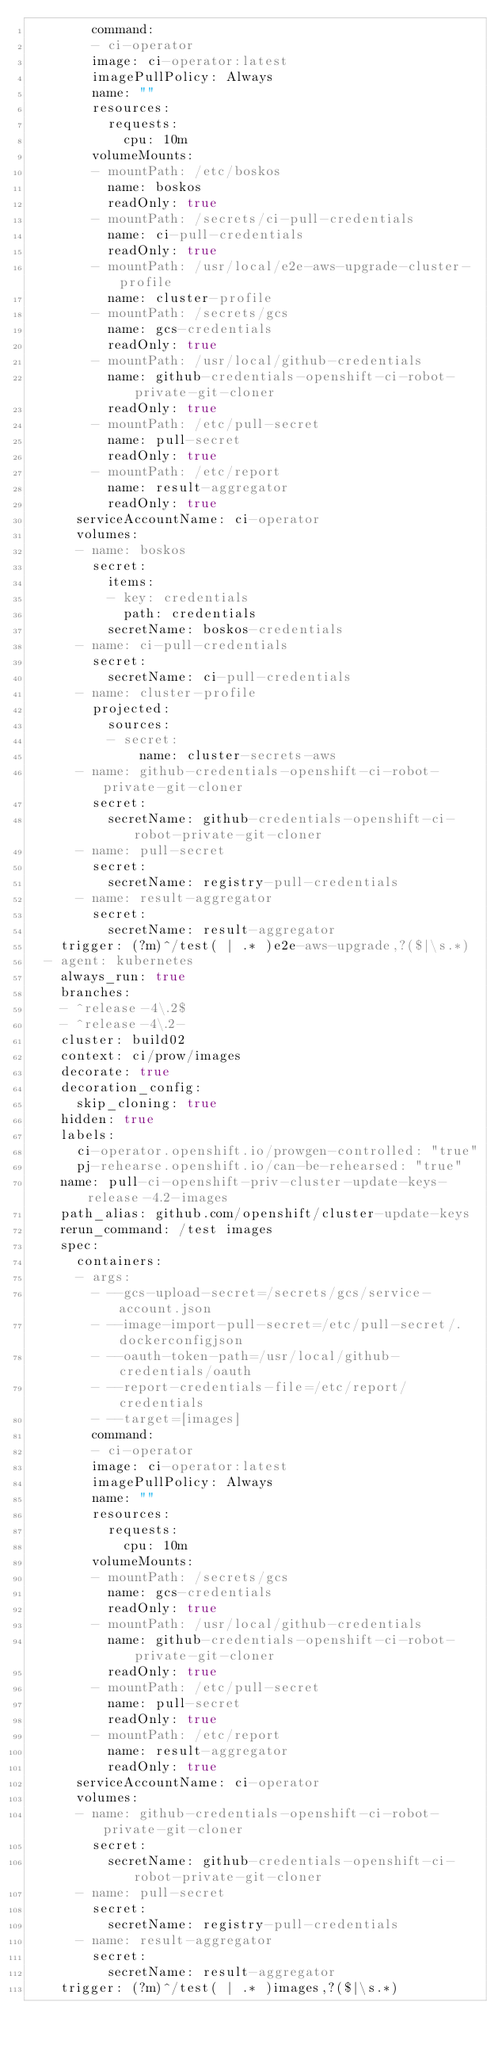<code> <loc_0><loc_0><loc_500><loc_500><_YAML_>        command:
        - ci-operator
        image: ci-operator:latest
        imagePullPolicy: Always
        name: ""
        resources:
          requests:
            cpu: 10m
        volumeMounts:
        - mountPath: /etc/boskos
          name: boskos
          readOnly: true
        - mountPath: /secrets/ci-pull-credentials
          name: ci-pull-credentials
          readOnly: true
        - mountPath: /usr/local/e2e-aws-upgrade-cluster-profile
          name: cluster-profile
        - mountPath: /secrets/gcs
          name: gcs-credentials
          readOnly: true
        - mountPath: /usr/local/github-credentials
          name: github-credentials-openshift-ci-robot-private-git-cloner
          readOnly: true
        - mountPath: /etc/pull-secret
          name: pull-secret
          readOnly: true
        - mountPath: /etc/report
          name: result-aggregator
          readOnly: true
      serviceAccountName: ci-operator
      volumes:
      - name: boskos
        secret:
          items:
          - key: credentials
            path: credentials
          secretName: boskos-credentials
      - name: ci-pull-credentials
        secret:
          secretName: ci-pull-credentials
      - name: cluster-profile
        projected:
          sources:
          - secret:
              name: cluster-secrets-aws
      - name: github-credentials-openshift-ci-robot-private-git-cloner
        secret:
          secretName: github-credentials-openshift-ci-robot-private-git-cloner
      - name: pull-secret
        secret:
          secretName: registry-pull-credentials
      - name: result-aggregator
        secret:
          secretName: result-aggregator
    trigger: (?m)^/test( | .* )e2e-aws-upgrade,?($|\s.*)
  - agent: kubernetes
    always_run: true
    branches:
    - ^release-4\.2$
    - ^release-4\.2-
    cluster: build02
    context: ci/prow/images
    decorate: true
    decoration_config:
      skip_cloning: true
    hidden: true
    labels:
      ci-operator.openshift.io/prowgen-controlled: "true"
      pj-rehearse.openshift.io/can-be-rehearsed: "true"
    name: pull-ci-openshift-priv-cluster-update-keys-release-4.2-images
    path_alias: github.com/openshift/cluster-update-keys
    rerun_command: /test images
    spec:
      containers:
      - args:
        - --gcs-upload-secret=/secrets/gcs/service-account.json
        - --image-import-pull-secret=/etc/pull-secret/.dockerconfigjson
        - --oauth-token-path=/usr/local/github-credentials/oauth
        - --report-credentials-file=/etc/report/credentials
        - --target=[images]
        command:
        - ci-operator
        image: ci-operator:latest
        imagePullPolicy: Always
        name: ""
        resources:
          requests:
            cpu: 10m
        volumeMounts:
        - mountPath: /secrets/gcs
          name: gcs-credentials
          readOnly: true
        - mountPath: /usr/local/github-credentials
          name: github-credentials-openshift-ci-robot-private-git-cloner
          readOnly: true
        - mountPath: /etc/pull-secret
          name: pull-secret
          readOnly: true
        - mountPath: /etc/report
          name: result-aggregator
          readOnly: true
      serviceAccountName: ci-operator
      volumes:
      - name: github-credentials-openshift-ci-robot-private-git-cloner
        secret:
          secretName: github-credentials-openshift-ci-robot-private-git-cloner
      - name: pull-secret
        secret:
          secretName: registry-pull-credentials
      - name: result-aggregator
        secret:
          secretName: result-aggregator
    trigger: (?m)^/test( | .* )images,?($|\s.*)
</code> 